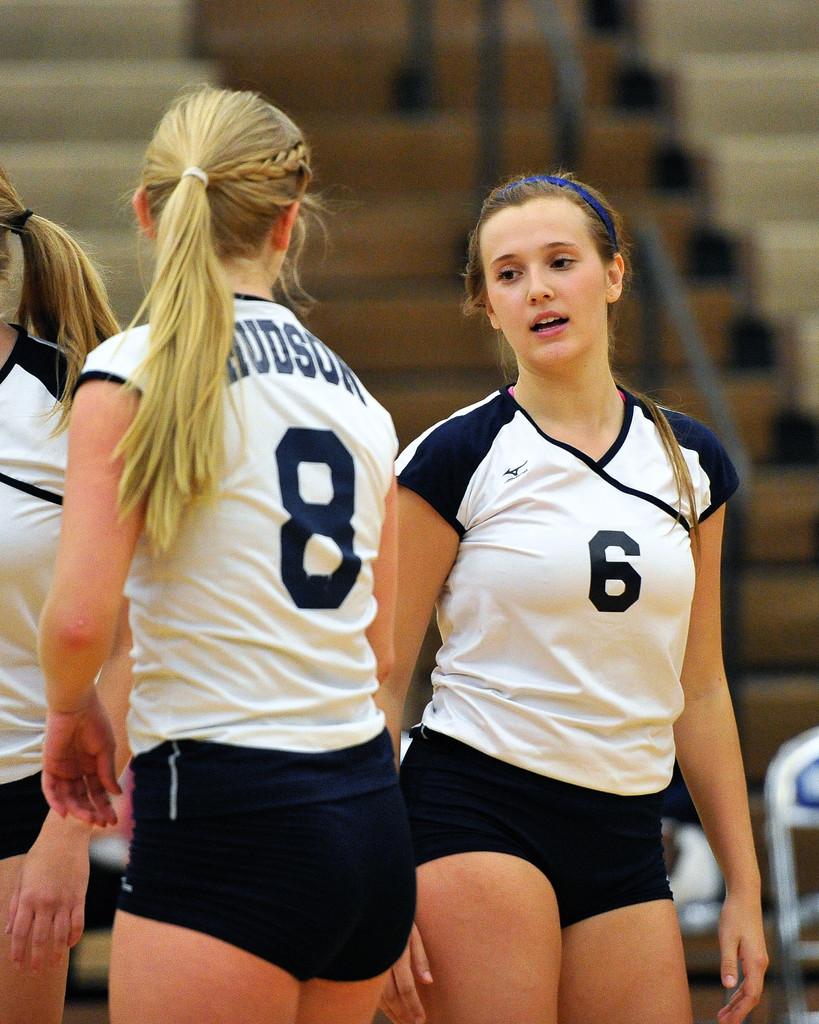What is a letter on the girl's shirt?
Your answer should be compact. U. 